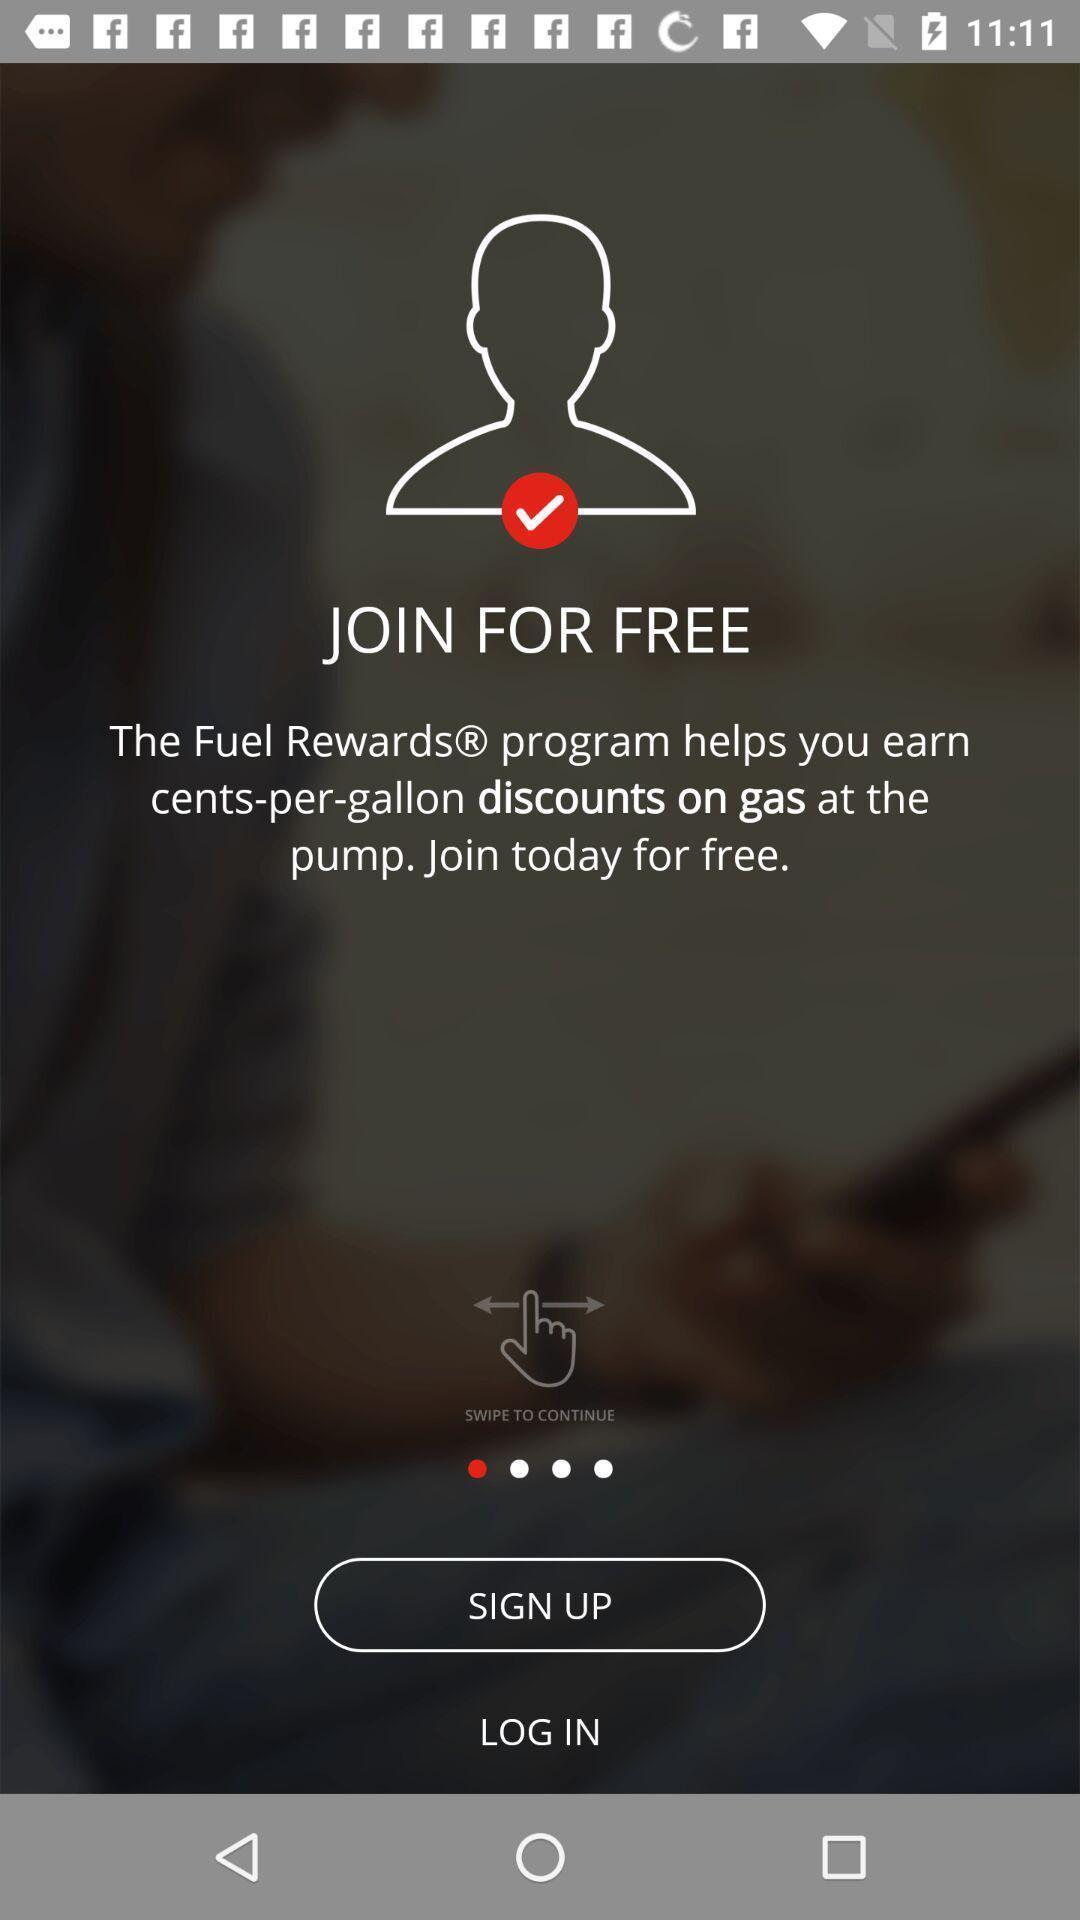Describe this image in words. Sign up page for a fuel booking app. 